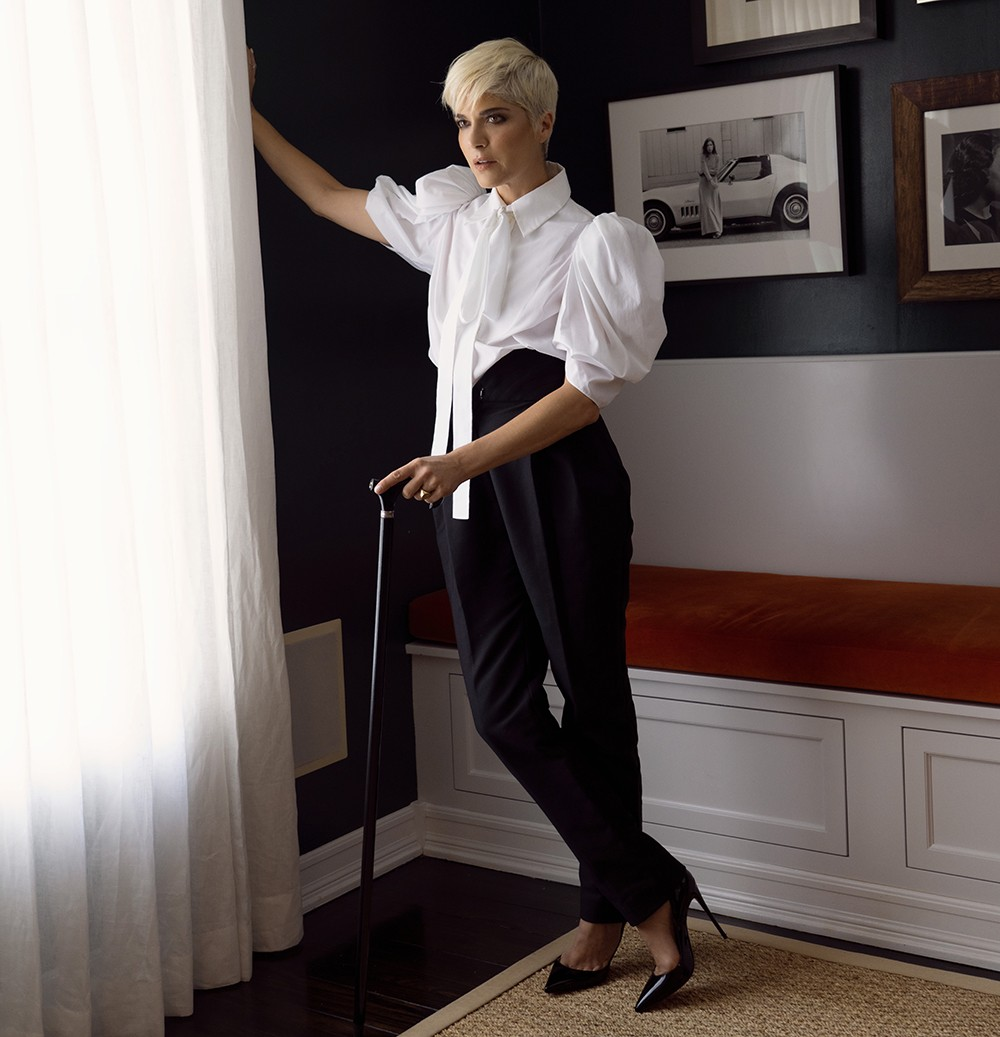Can you describe the setting in which the photo was taken? The setting of the photo is an elegantly designed room with a strong monochrome theme. The walls are painted a striking black, creating a bold backdrop for the subject. To the side, a white curtain filters soft light into the room, adding depth and contrast. The subject stands next to a bench with a cozy orange cushion, bringing a touch of warmth to the otherwise neutral palette. Pictures and frames hang on the wall, including an intriguing photo of a car, adding layers of character to the space. What do you think the photo of the car on the wall signifies? The photo of the car on the wall could symbolize freedom, journey, or personal milestones. It adds an element of storytelling to the scene, suggesting that the subject's environment is deeply personal and filled with meaningful artifacts. The car might represent a significant journey or chapter in her life, serving as a reminder of past experiences and the roads she has traveled. 